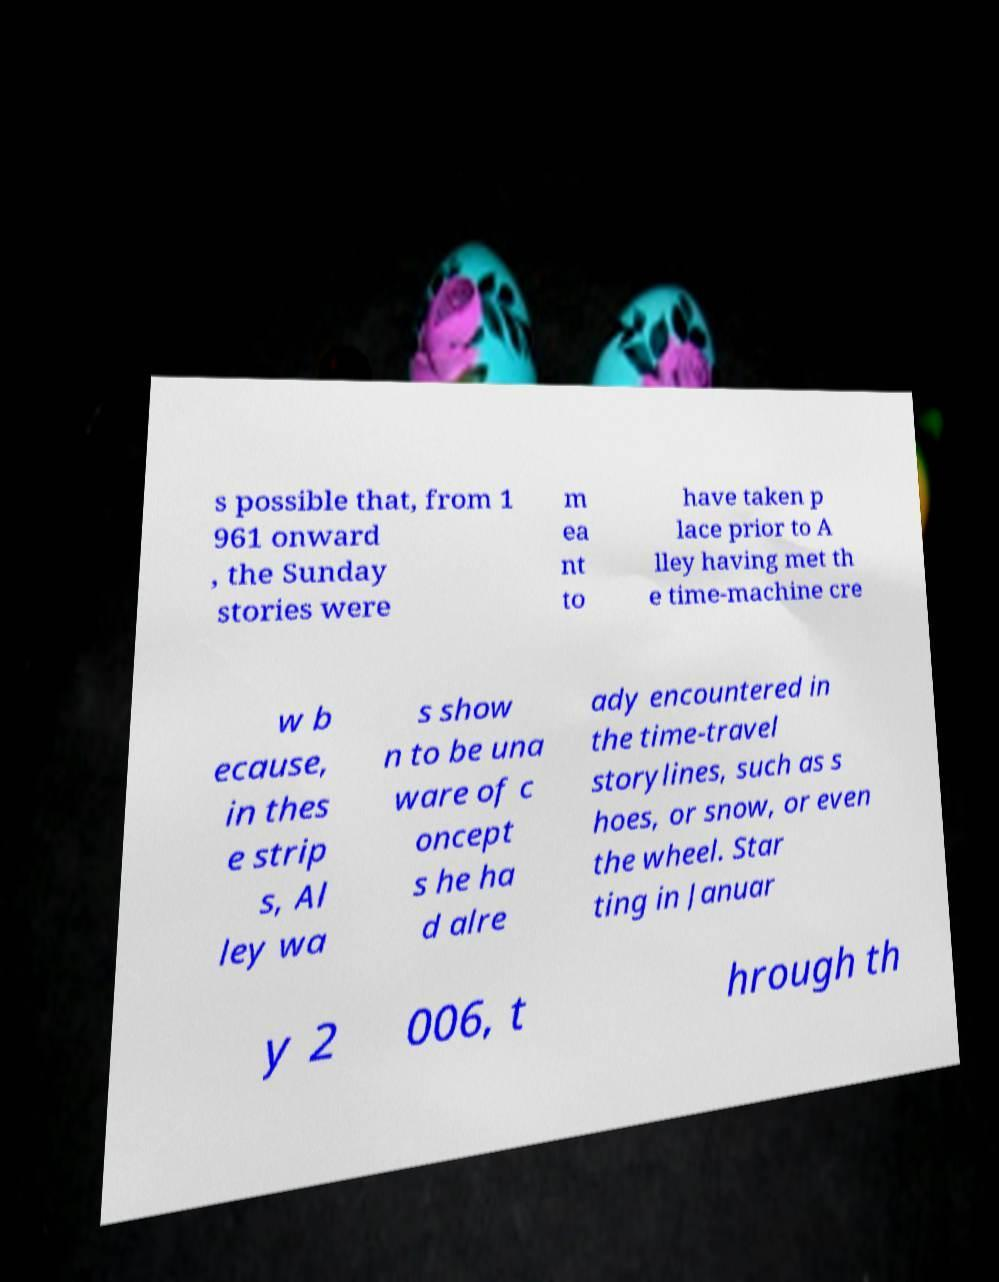There's text embedded in this image that I need extracted. Can you transcribe it verbatim? s possible that, from 1 961 onward , the Sunday stories were m ea nt to have taken p lace prior to A lley having met th e time-machine cre w b ecause, in thes e strip s, Al ley wa s show n to be una ware of c oncept s he ha d alre ady encountered in the time-travel storylines, such as s hoes, or snow, or even the wheel. Star ting in Januar y 2 006, t hrough th 